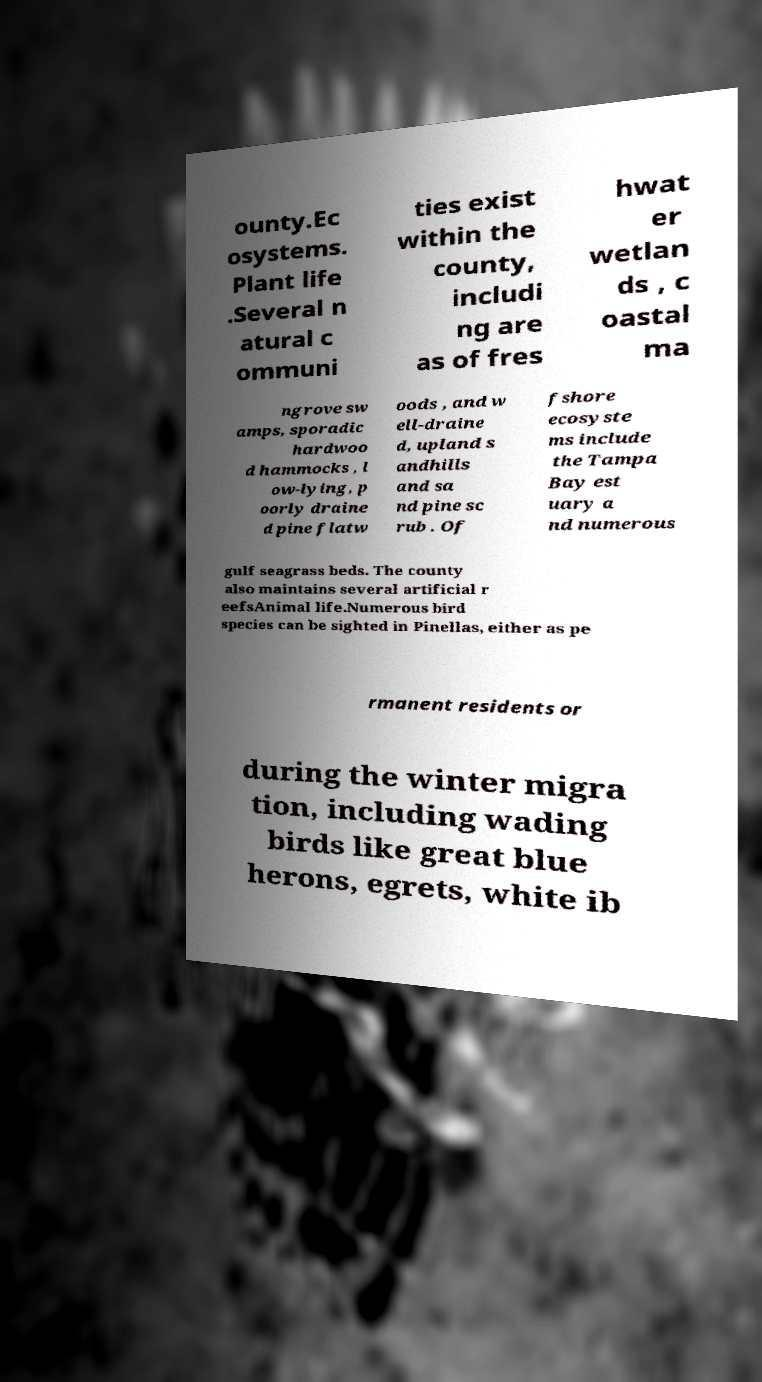Please identify and transcribe the text found in this image. ounty.Ec osystems. Plant life .Several n atural c ommuni ties exist within the county, includi ng are as of fres hwat er wetlan ds , c oastal ma ngrove sw amps, sporadic hardwoo d hammocks , l ow-lying, p oorly draine d pine flatw oods , and w ell-draine d, upland s andhills and sa nd pine sc rub . Of fshore ecosyste ms include the Tampa Bay est uary a nd numerous gulf seagrass beds. The county also maintains several artificial r eefsAnimal life.Numerous bird species can be sighted in Pinellas, either as pe rmanent residents or during the winter migra tion, including wading birds like great blue herons, egrets, white ib 